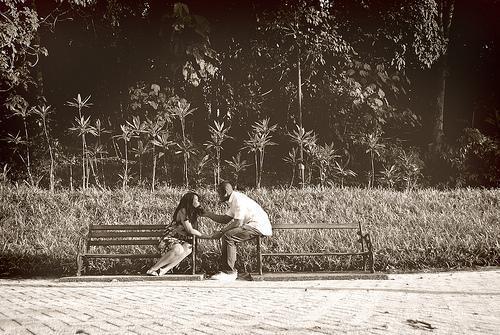How many people are there?
Give a very brief answer. 2. 